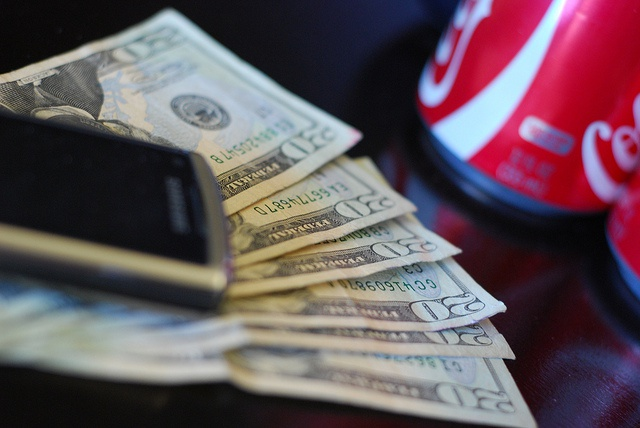Describe the objects in this image and their specific colors. I can see a cell phone in black, gray, and tan tones in this image. 